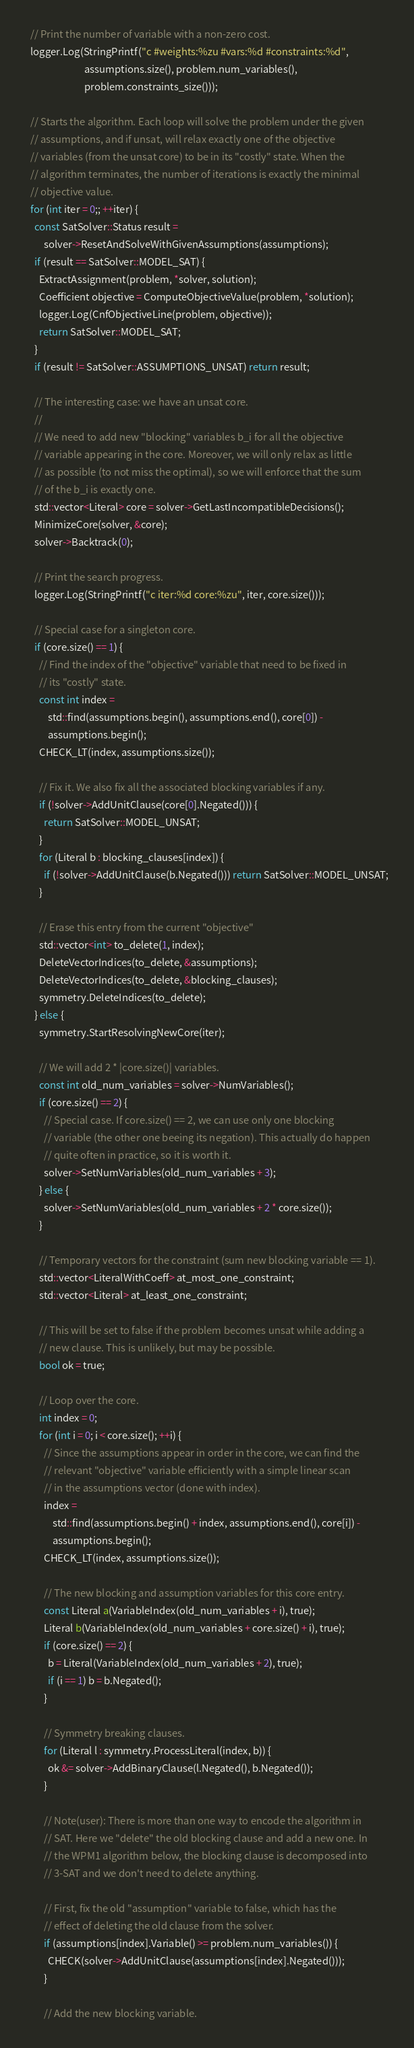Convert code to text. <code><loc_0><loc_0><loc_500><loc_500><_C++_>  // Print the number of variable with a non-zero cost.
  logger.Log(StringPrintf("c #weights:%zu #vars:%d #constraints:%d",
                          assumptions.size(), problem.num_variables(),
                          problem.constraints_size()));

  // Starts the algorithm. Each loop will solve the problem under the given
  // assumptions, and if unsat, will relax exactly one of the objective
  // variables (from the unsat core) to be in its "costly" state. When the
  // algorithm terminates, the number of iterations is exactly the minimal
  // objective value.
  for (int iter = 0;; ++iter) {
    const SatSolver::Status result =
        solver->ResetAndSolveWithGivenAssumptions(assumptions);
    if (result == SatSolver::MODEL_SAT) {
      ExtractAssignment(problem, *solver, solution);
      Coefficient objective = ComputeObjectiveValue(problem, *solution);
      logger.Log(CnfObjectiveLine(problem, objective));
      return SatSolver::MODEL_SAT;
    }
    if (result != SatSolver::ASSUMPTIONS_UNSAT) return result;

    // The interesting case: we have an unsat core.
    //
    // We need to add new "blocking" variables b_i for all the objective
    // variable appearing in the core. Moreover, we will only relax as little
    // as possible (to not miss the optimal), so we will enforce that the sum
    // of the b_i is exactly one.
    std::vector<Literal> core = solver->GetLastIncompatibleDecisions();
    MinimizeCore(solver, &core);
    solver->Backtrack(0);

    // Print the search progress.
    logger.Log(StringPrintf("c iter:%d core:%zu", iter, core.size()));

    // Special case for a singleton core.
    if (core.size() == 1) {
      // Find the index of the "objective" variable that need to be fixed in
      // its "costly" state.
      const int index =
          std::find(assumptions.begin(), assumptions.end(), core[0]) -
          assumptions.begin();
      CHECK_LT(index, assumptions.size());

      // Fix it. We also fix all the associated blocking variables if any.
      if (!solver->AddUnitClause(core[0].Negated())) {
        return SatSolver::MODEL_UNSAT;
      }
      for (Literal b : blocking_clauses[index]) {
        if (!solver->AddUnitClause(b.Negated())) return SatSolver::MODEL_UNSAT;
      }

      // Erase this entry from the current "objective"
      std::vector<int> to_delete(1, index);
      DeleteVectorIndices(to_delete, &assumptions);
      DeleteVectorIndices(to_delete, &blocking_clauses);
      symmetry.DeleteIndices(to_delete);
    } else {
      symmetry.StartResolvingNewCore(iter);

      // We will add 2 * |core.size()| variables.
      const int old_num_variables = solver->NumVariables();
      if (core.size() == 2) {
        // Special case. If core.size() == 2, we can use only one blocking
        // variable (the other one beeing its negation). This actually do happen
        // quite often in practice, so it is worth it.
        solver->SetNumVariables(old_num_variables + 3);
      } else {
        solver->SetNumVariables(old_num_variables + 2 * core.size());
      }

      // Temporary vectors for the constraint (sum new blocking variable == 1).
      std::vector<LiteralWithCoeff> at_most_one_constraint;
      std::vector<Literal> at_least_one_constraint;

      // This will be set to false if the problem becomes unsat while adding a
      // new clause. This is unlikely, but may be possible.
      bool ok = true;

      // Loop over the core.
      int index = 0;
      for (int i = 0; i < core.size(); ++i) {
        // Since the assumptions appear in order in the core, we can find the
        // relevant "objective" variable efficiently with a simple linear scan
        // in the assumptions vector (done with index).
        index =
            std::find(assumptions.begin() + index, assumptions.end(), core[i]) -
            assumptions.begin();
        CHECK_LT(index, assumptions.size());

        // The new blocking and assumption variables for this core entry.
        const Literal a(VariableIndex(old_num_variables + i), true);
        Literal b(VariableIndex(old_num_variables + core.size() + i), true);
        if (core.size() == 2) {
          b = Literal(VariableIndex(old_num_variables + 2), true);
          if (i == 1) b = b.Negated();
        }

        // Symmetry breaking clauses.
        for (Literal l : symmetry.ProcessLiteral(index, b)) {
          ok &= solver->AddBinaryClause(l.Negated(), b.Negated());
        }

        // Note(user): There is more than one way to encode the algorithm in
        // SAT. Here we "delete" the old blocking clause and add a new one. In
        // the WPM1 algorithm below, the blocking clause is decomposed into
        // 3-SAT and we don't need to delete anything.

        // First, fix the old "assumption" variable to false, which has the
        // effect of deleting the old clause from the solver.
        if (assumptions[index].Variable() >= problem.num_variables()) {
          CHECK(solver->AddUnitClause(assumptions[index].Negated()));
        }

        // Add the new blocking variable.</code> 